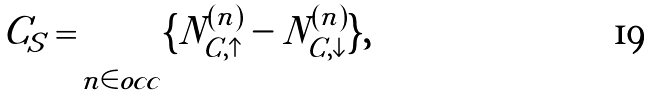Convert formula to latex. <formula><loc_0><loc_0><loc_500><loc_500>C _ { S } = \sum _ { n \in o c c } \{ N ^ { ( n ) } _ { C , \uparrow } - N ^ { ( n ) } _ { C , \downarrow } \} ,</formula> 